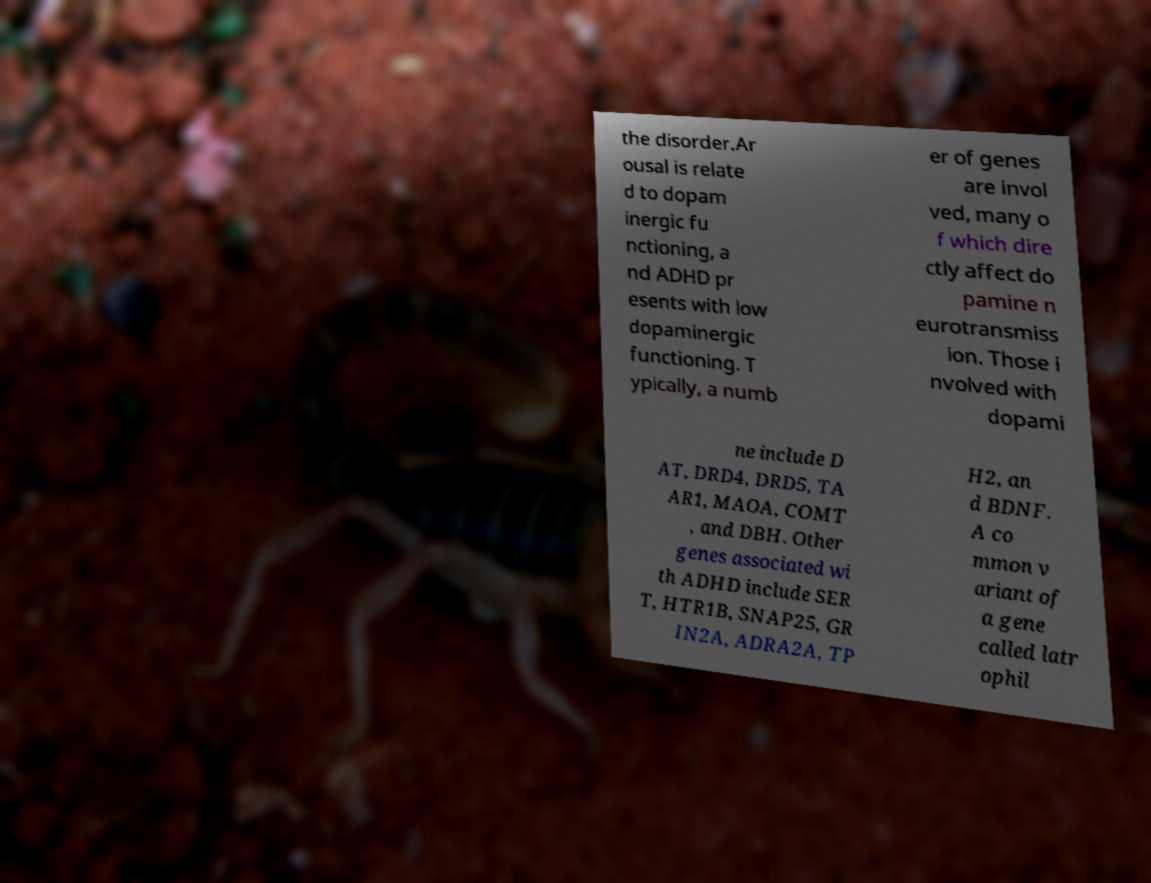Please read and relay the text visible in this image. What does it say? the disorder.Ar ousal is relate d to dopam inergic fu nctioning, a nd ADHD pr esents with low dopaminergic functioning. T ypically, a numb er of genes are invol ved, many o f which dire ctly affect do pamine n eurotransmiss ion. Those i nvolved with dopami ne include D AT, DRD4, DRD5, TA AR1, MAOA, COMT , and DBH. Other genes associated wi th ADHD include SER T, HTR1B, SNAP25, GR IN2A, ADRA2A, TP H2, an d BDNF. A co mmon v ariant of a gene called latr ophil 